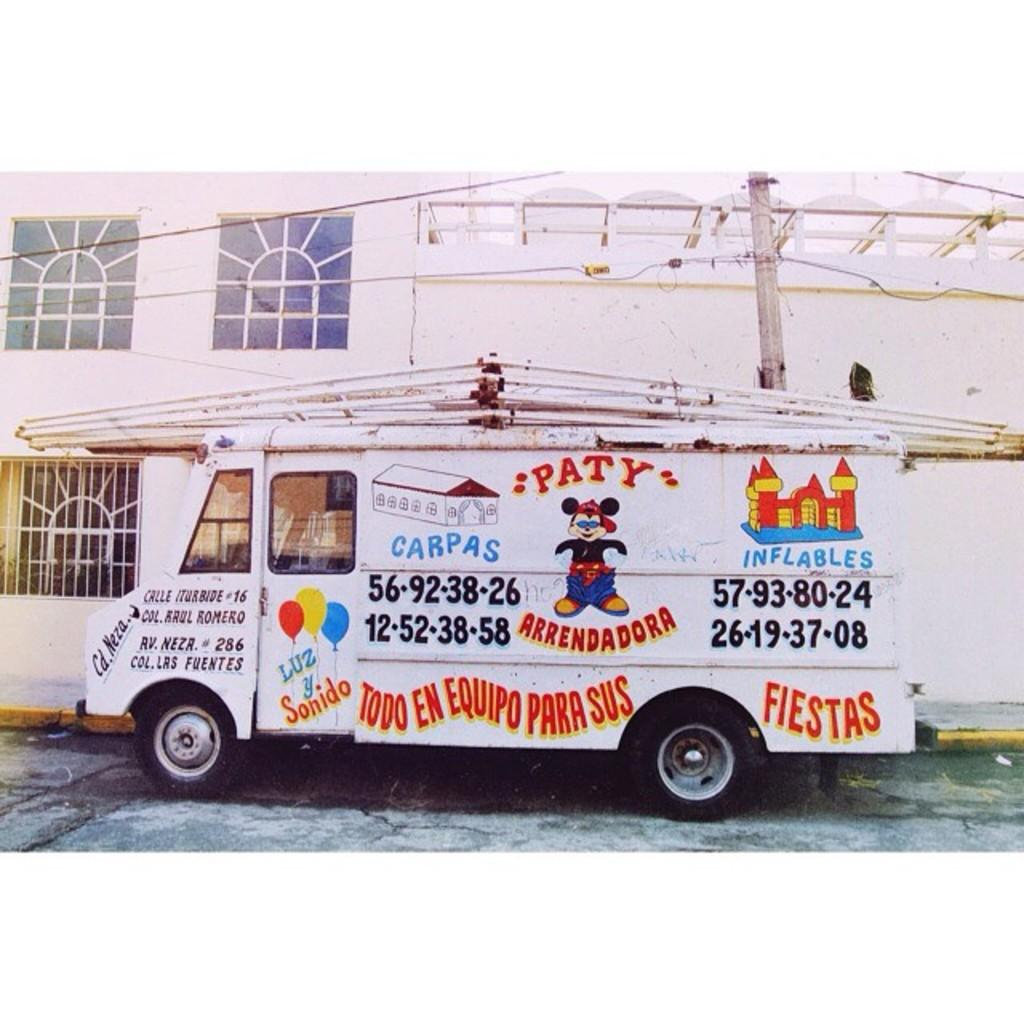Provide a one-sentence caption for the provided image. A white truck with a bouncy house and a phone number and words in a foreign language on it. 